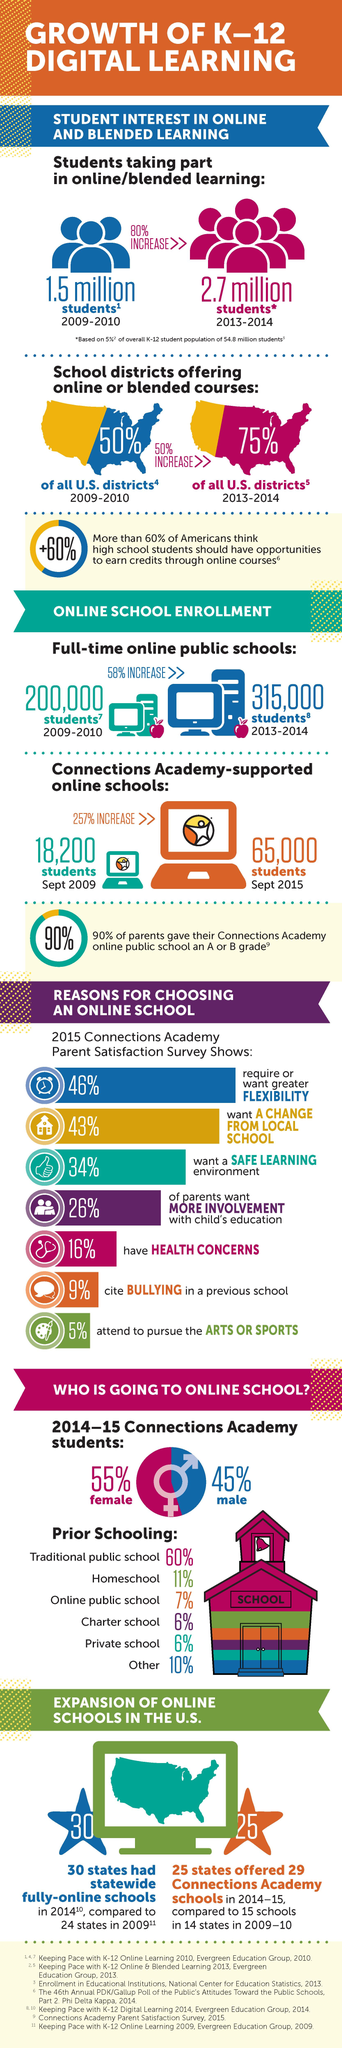Indicate a few pertinent items in this graphic. From September 2009 to September 2015, the number of students enrolled in Connections Academy supported online schools increased by 46,800. In a survey of parents who switched their children from regular schools to online schools for safety and health reasons, a majority, or 50%, reported wanting to do so for these reasons. There was a significant increase in the number of K-12 students participating in online learning from the school year 2009-2010 to 2013-2014, with an approximate rise of 1.2 million students. Between the school years 2009-2010 and 2013-2014, a total of 1,15,000 students have increased their enrollment in full-time online public schools. The percentage of females and males attending online schools varies with a difference of 10%. 